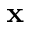Convert formula to latex. <formula><loc_0><loc_0><loc_500><loc_500>x</formula> 